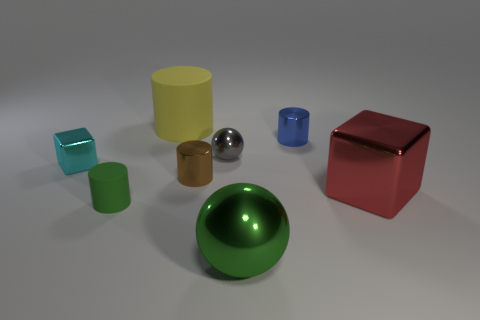Can you describe the shapes and materials of the objects in the image? Certainly! There are a variety of geometric shapes, including cylinders, spheres, and cubes, each with different surface finishes ranging from matte to shiny, suggesting a mixture of materials like plastic, metal, and glass. 